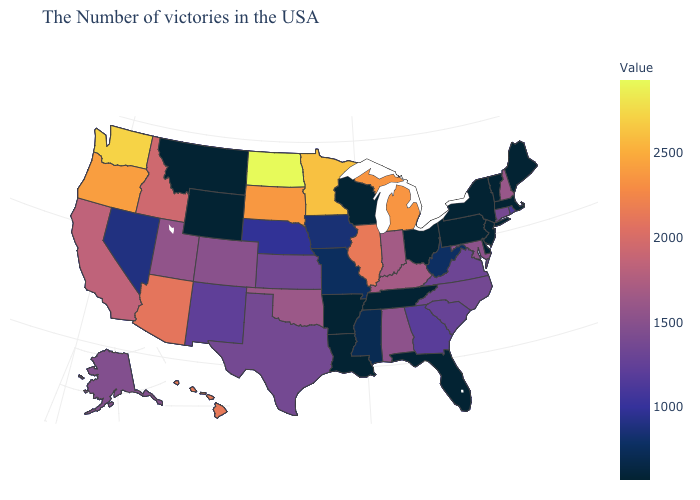Does the map have missing data?
Quick response, please. No. Does the map have missing data?
Keep it brief. No. Does Iowa have a lower value than Washington?
Be succinct. Yes. 